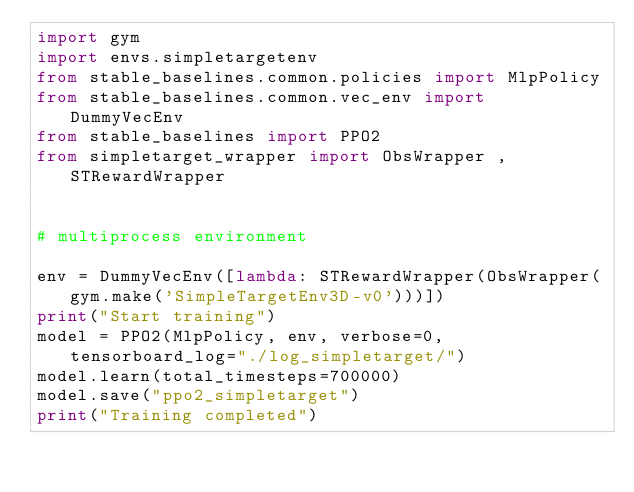<code> <loc_0><loc_0><loc_500><loc_500><_Python_>import gym
import envs.simpletargetenv
from stable_baselines.common.policies import MlpPolicy
from stable_baselines.common.vec_env import DummyVecEnv
from stable_baselines import PPO2
from simpletarget_wrapper import ObsWrapper , STRewardWrapper


# multiprocess environment

env = DummyVecEnv([lambda: STRewardWrapper(ObsWrapper(gym.make('SimpleTargetEnv3D-v0')))])
print("Start training")
model = PPO2(MlpPolicy, env, verbose=0, tensorboard_log="./log_simpletarget/")
model.learn(total_timesteps=700000)
model.save("ppo2_simpletarget")
print("Training completed")
</code> 